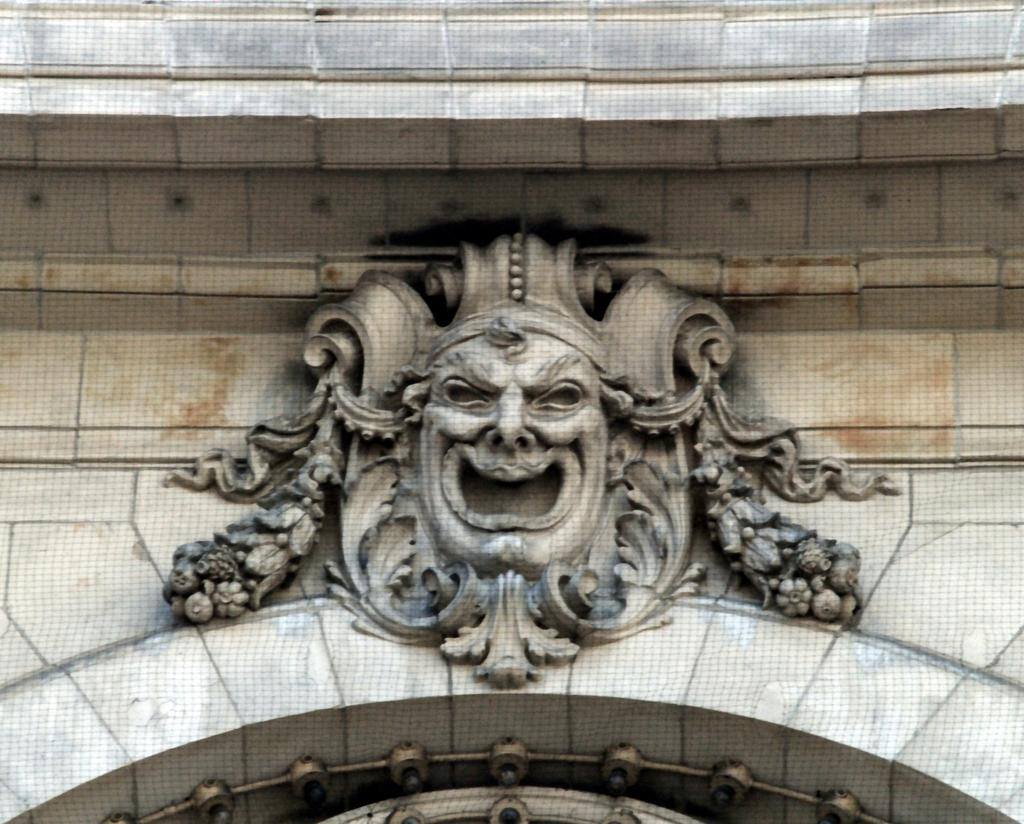What can be seen on the wall in the image? There is carving on the wall in the image. What is the color of the carving? The carving is in grey color. How many tomatoes are on the giraffe's back in the image? There is no giraffe or tomatoes present in the image; it only features carving on the wall. 